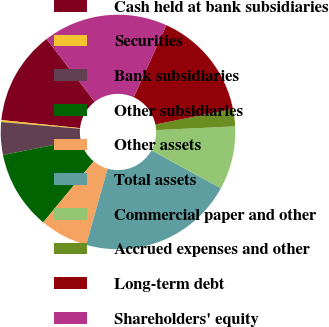Convert chart to OTSL. <chart><loc_0><loc_0><loc_500><loc_500><pie_chart><fcel>Cash held at bank subsidiaries<fcel>Securities<fcel>Bank subsidiaries<fcel>Other subsidiaries<fcel>Other assets<fcel>Total assets<fcel>Commercial paper and other<fcel>Accrued expenses and other<fcel>Long-term debt<fcel>Shareholders' equity<nl><fcel>12.96%<fcel>0.27%<fcel>4.5%<fcel>10.85%<fcel>6.62%<fcel>21.42%<fcel>8.73%<fcel>2.39%<fcel>15.07%<fcel>17.19%<nl></chart> 